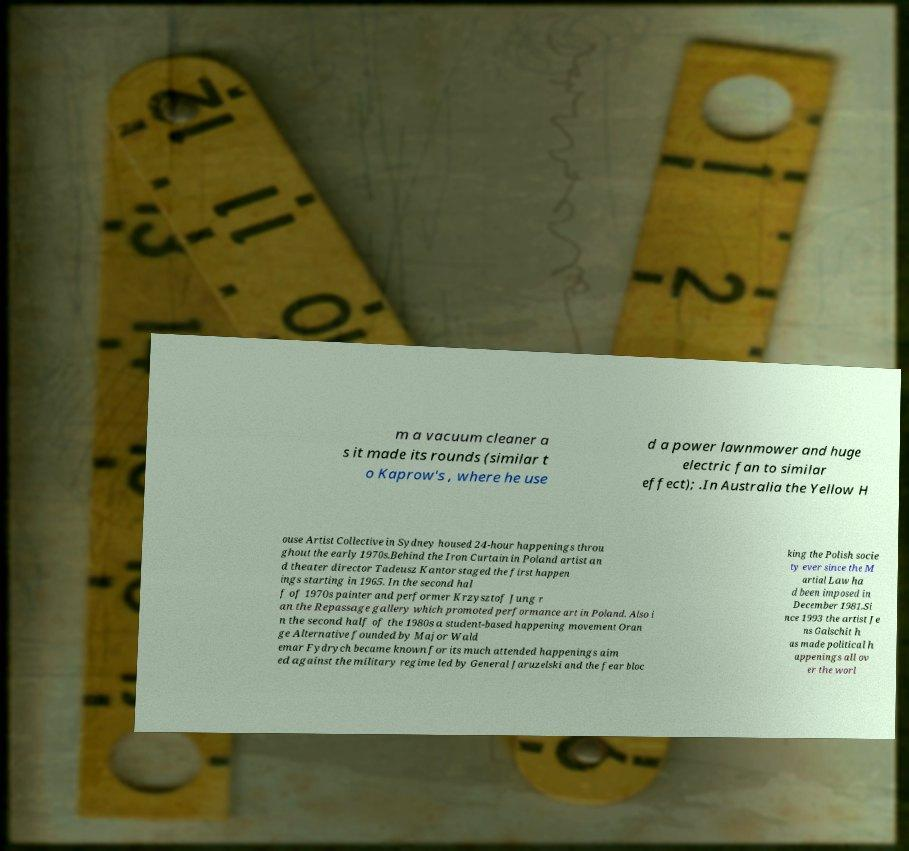Could you assist in decoding the text presented in this image and type it out clearly? m a vacuum cleaner a s it made its rounds (similar t o Kaprow's , where he use d a power lawnmower and huge electric fan to similar effect); .In Australia the Yellow H ouse Artist Collective in Sydney housed 24-hour happenings throu ghout the early 1970s.Behind the Iron Curtain in Poland artist an d theater director Tadeusz Kantor staged the first happen ings starting in 1965. In the second hal f of 1970s painter and performer Krzysztof Jung r an the Repassage gallery which promoted performance art in Poland. Also i n the second half of the 1980s a student-based happening movement Oran ge Alternative founded by Major Wald emar Fydrych became known for its much attended happenings aim ed against the military regime led by General Jaruzelski and the fear bloc king the Polish socie ty ever since the M artial Law ha d been imposed in December 1981.Si nce 1993 the artist Je ns Galschit h as made political h appenings all ov er the worl 